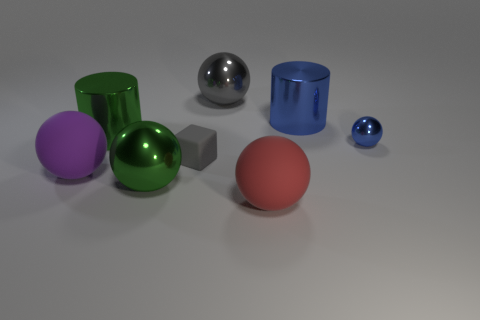Subtract all gray balls. How many balls are left? 4 Subtract all big red rubber balls. How many balls are left? 4 Subtract all cyan balls. Subtract all yellow cylinders. How many balls are left? 5 Add 1 large metallic spheres. How many objects exist? 9 Subtract all balls. How many objects are left? 3 Subtract all big green metallic things. Subtract all blue objects. How many objects are left? 4 Add 7 big green metallic objects. How many big green metallic objects are left? 9 Add 2 small things. How many small things exist? 4 Subtract 0 red blocks. How many objects are left? 8 